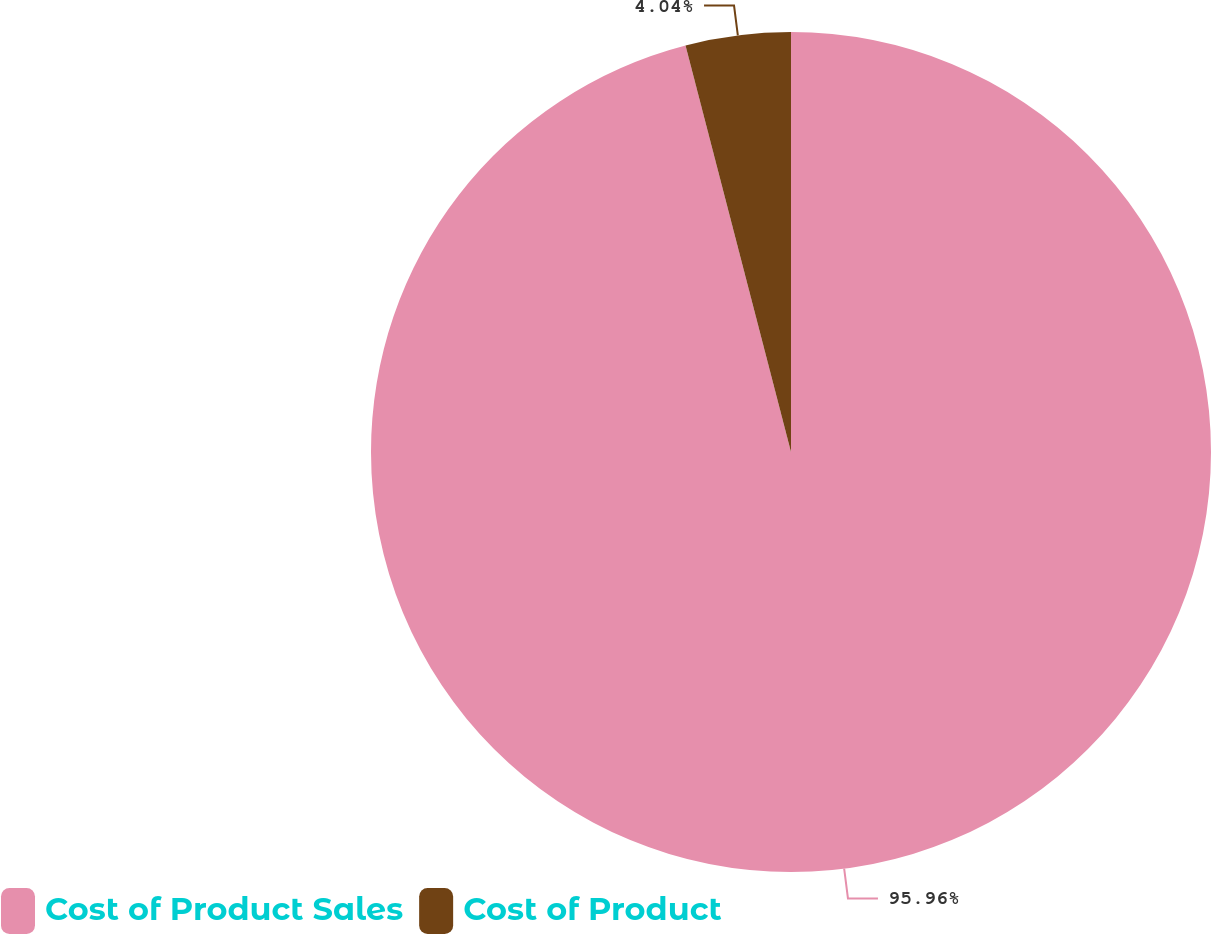Convert chart. <chart><loc_0><loc_0><loc_500><loc_500><pie_chart><fcel>Cost of Product Sales<fcel>Cost of Product<nl><fcel>95.96%<fcel>4.04%<nl></chart> 